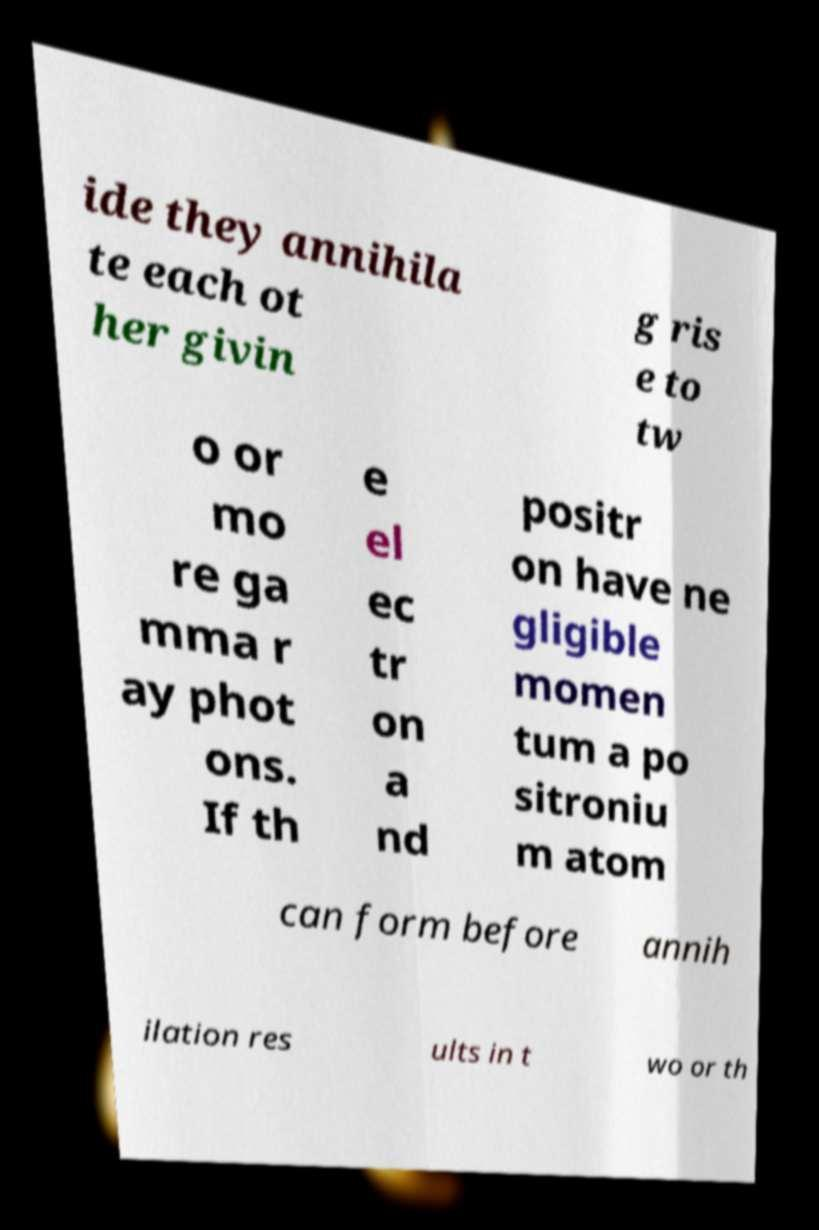Please identify and transcribe the text found in this image. ide they annihila te each ot her givin g ris e to tw o or mo re ga mma r ay phot ons. If th e el ec tr on a nd positr on have ne gligible momen tum a po sitroniu m atom can form before annih ilation res ults in t wo or th 